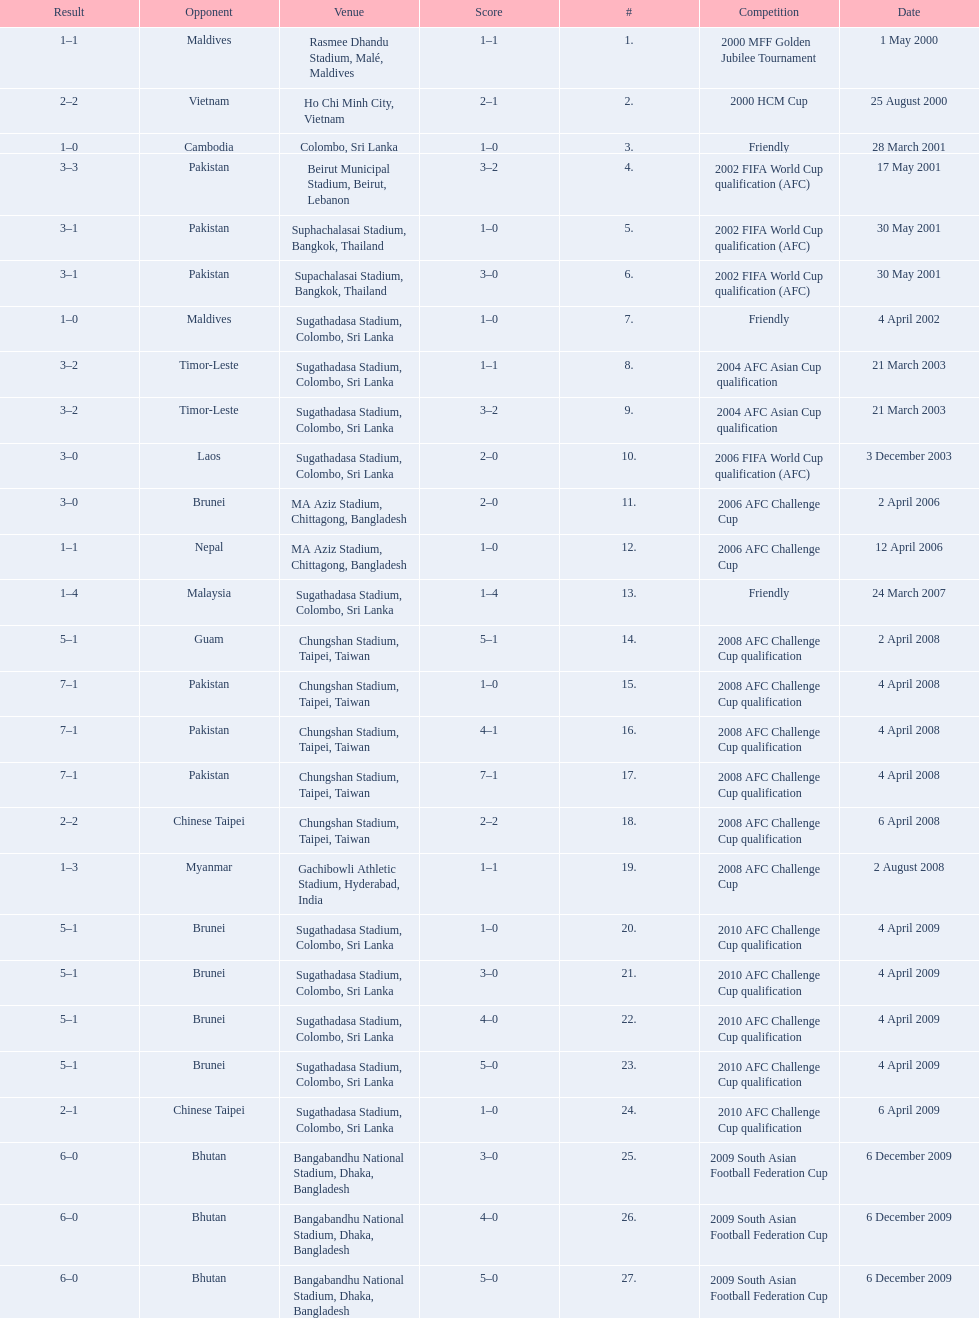What are the venues Rasmee Dhandu Stadium, Malé, Maldives, Ho Chi Minh City, Vietnam, Colombo, Sri Lanka, Beirut Municipal Stadium, Beirut, Lebanon, Suphachalasai Stadium, Bangkok, Thailand, Supachalasai Stadium, Bangkok, Thailand, Sugathadasa Stadium, Colombo, Sri Lanka, Sugathadasa Stadium, Colombo, Sri Lanka, Sugathadasa Stadium, Colombo, Sri Lanka, Sugathadasa Stadium, Colombo, Sri Lanka, MA Aziz Stadium, Chittagong, Bangladesh, MA Aziz Stadium, Chittagong, Bangladesh, Sugathadasa Stadium, Colombo, Sri Lanka, Chungshan Stadium, Taipei, Taiwan, Chungshan Stadium, Taipei, Taiwan, Chungshan Stadium, Taipei, Taiwan, Chungshan Stadium, Taipei, Taiwan, Chungshan Stadium, Taipei, Taiwan, Gachibowli Athletic Stadium, Hyderabad, India, Sugathadasa Stadium, Colombo, Sri Lanka, Sugathadasa Stadium, Colombo, Sri Lanka, Sugathadasa Stadium, Colombo, Sri Lanka, Sugathadasa Stadium, Colombo, Sri Lanka, Sugathadasa Stadium, Colombo, Sri Lanka, Bangabandhu National Stadium, Dhaka, Bangladesh, Bangabandhu National Stadium, Dhaka, Bangladesh, Bangabandhu National Stadium, Dhaka, Bangladesh. What are the #'s? 1., 2., 3., 4., 5., 6., 7., 8., 9., 10., 11., 12., 13., 14., 15., 16., 17., 18., 19., 20., 21., 22., 23., 24., 25., 26., 27. Which one is #1? Rasmee Dhandu Stadium, Malé, Maldives. 